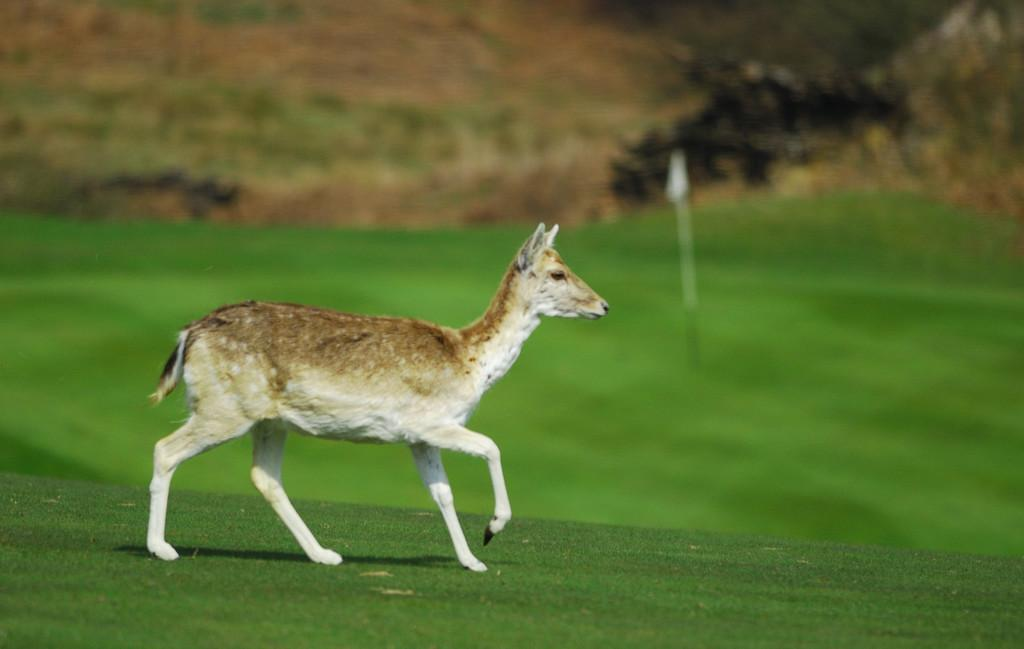What animal is in the foreground of the image? There is a deer in the foreground of the image. What is the deer doing in the image? The deer is walking on the grass. What can be seen in the background of the image? There is a flag in the background of the image. Where is the flag located in the image? The flag is on the grass in the background. Can you describe the top part of the image? The top part of the image is blurred. How many dogs are walking with the deer in the image? There are no dogs present in the image; it features a deer walking on the grass. What is the woman doing in the image? There is no woman present in the image. 